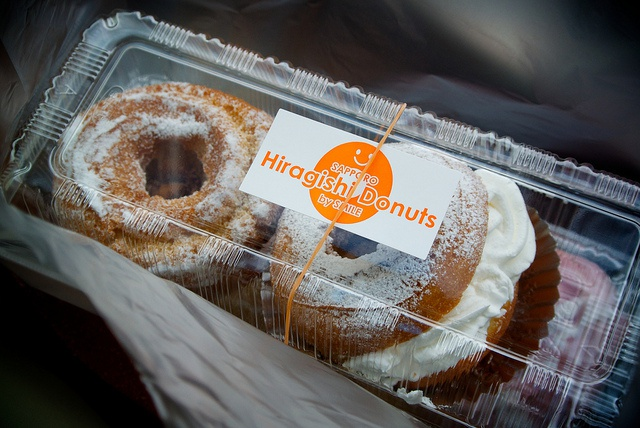Describe the objects in this image and their specific colors. I can see donut in black, darkgray, lightgray, gray, and maroon tones and donut in black, darkgray, gray, and tan tones in this image. 